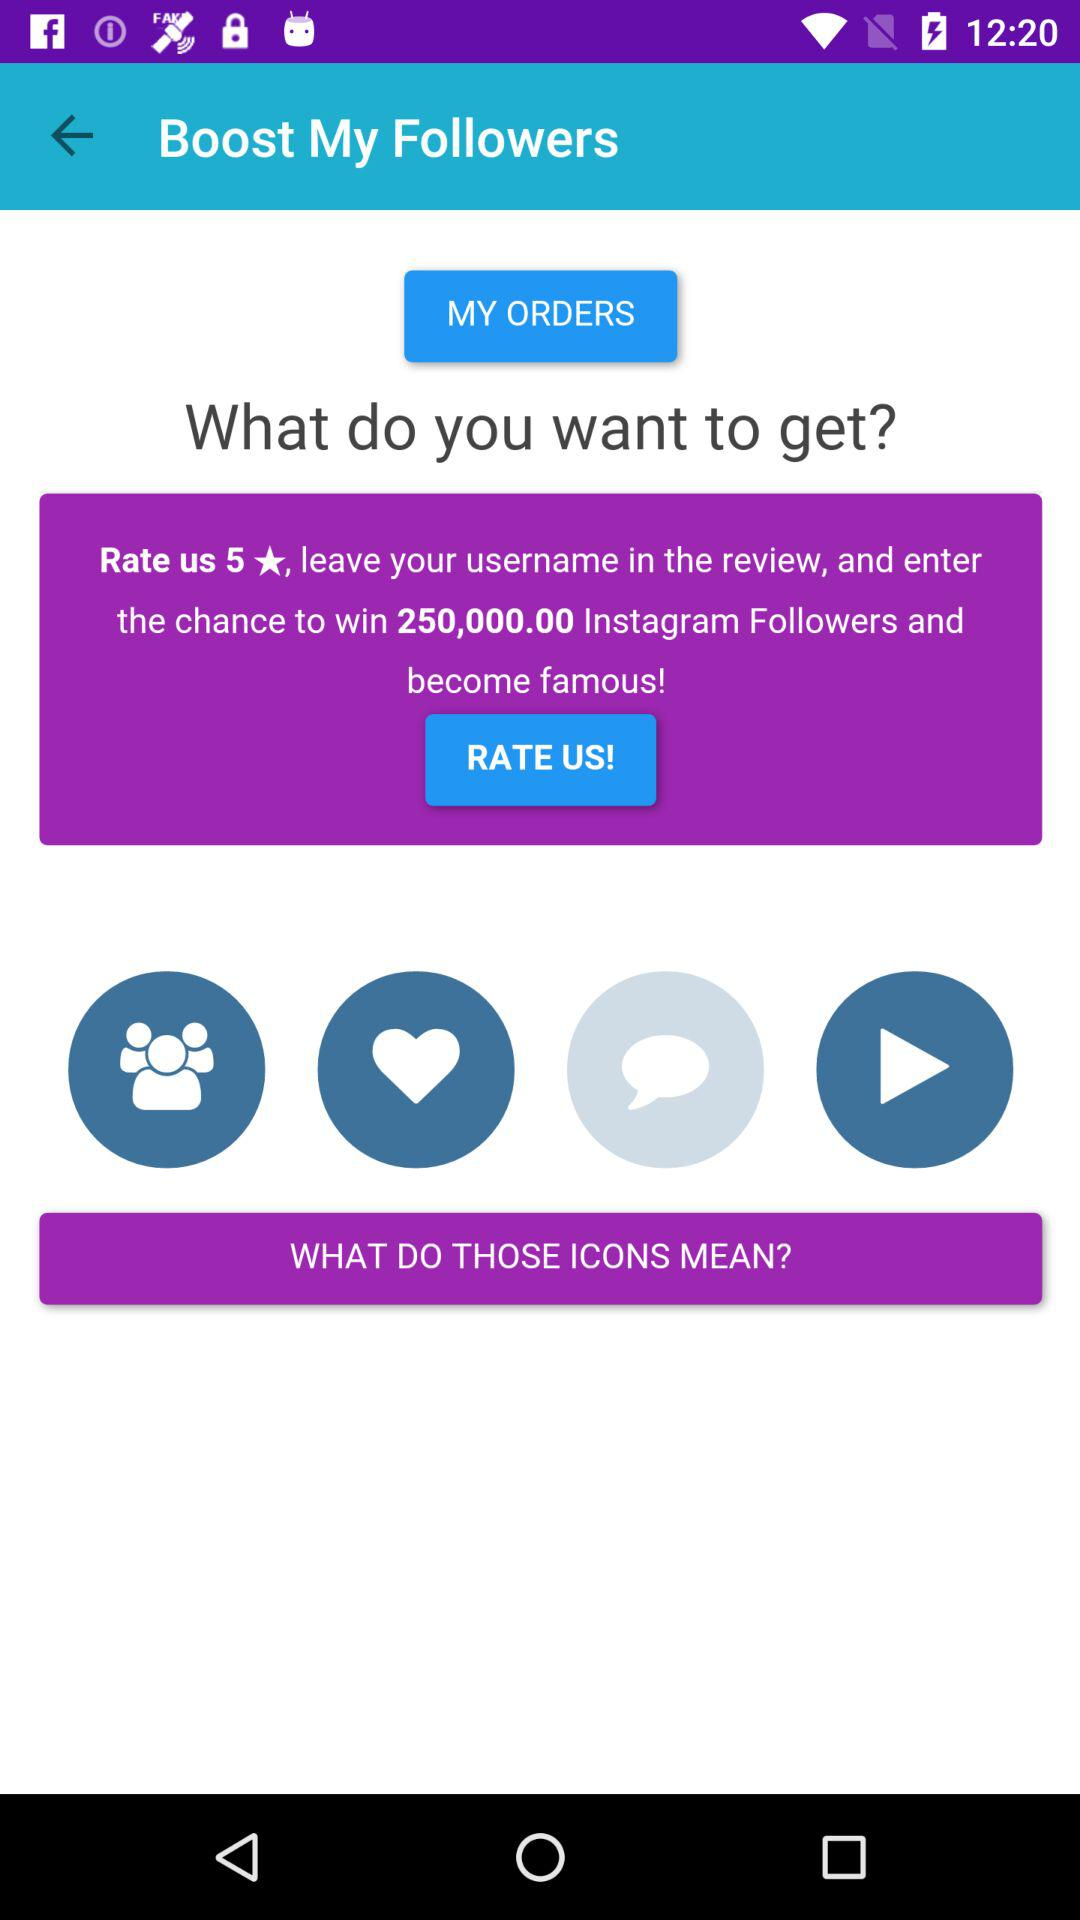By giving how many stars in the rating, can 250000 Instagram followers be earned? By giving 5 stars in the rating, 250000 Instagram followers can be earned. 